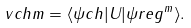Convert formula to latex. <formula><loc_0><loc_0><loc_500><loc_500>\ v c h m = \langle \psi c h | U | \psi r e g ^ { m } \rangle .</formula> 